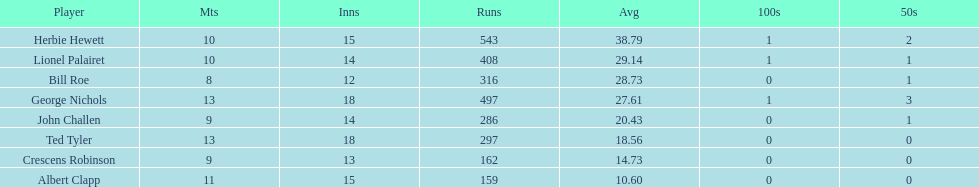How many players played more than 10 matches? 3. 